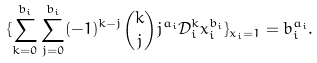<formula> <loc_0><loc_0><loc_500><loc_500>\{ \sum _ { k = 0 } ^ { b _ { i } } \sum _ { j = 0 } ^ { b _ { i } } ( - 1 ) ^ { k - j } { k \choose j } j ^ { a _ { i } } \mathcal { D } _ { i } ^ { k } x _ { i } ^ { b _ { i } } \} _ { x _ { i } = 1 } = b _ { i } ^ { a _ { i } } .</formula> 